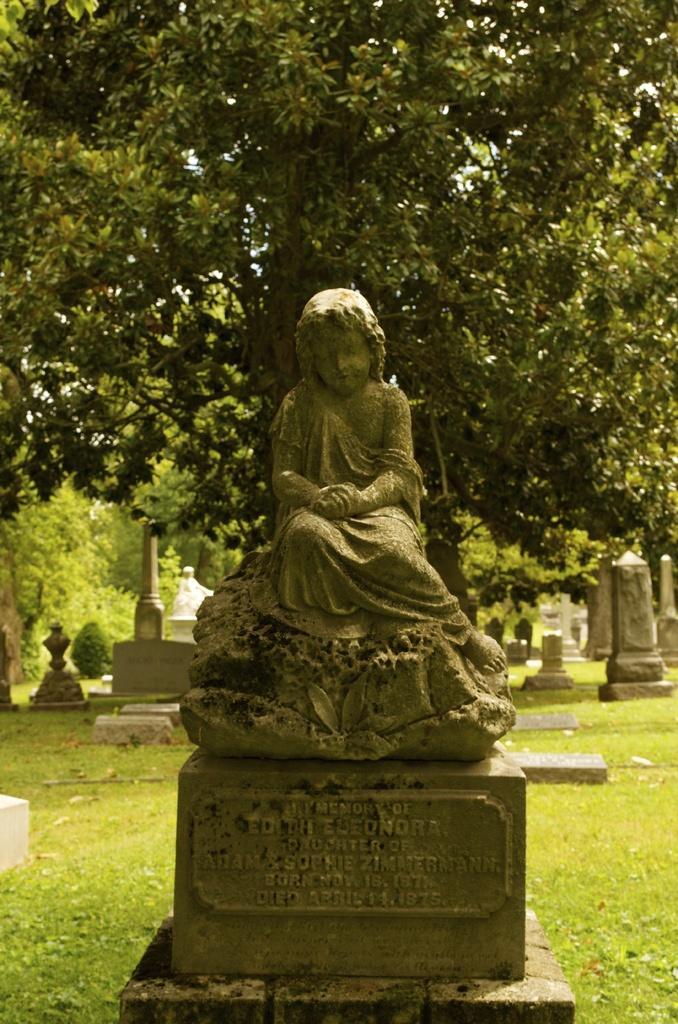Describe this image in one or two sentences. In the image there is a statue in the middle of garden with a tree behind it along with some statues on either side of it. 